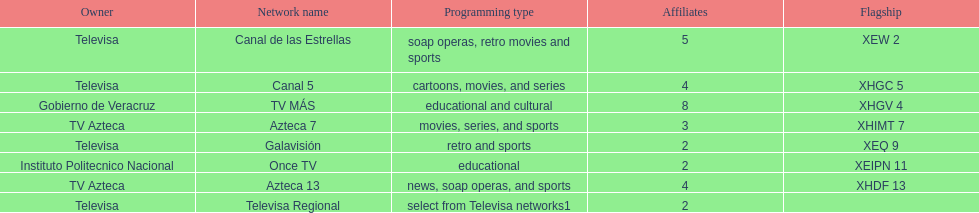What is the number of affiliates of canal de las estrellas. 5. 